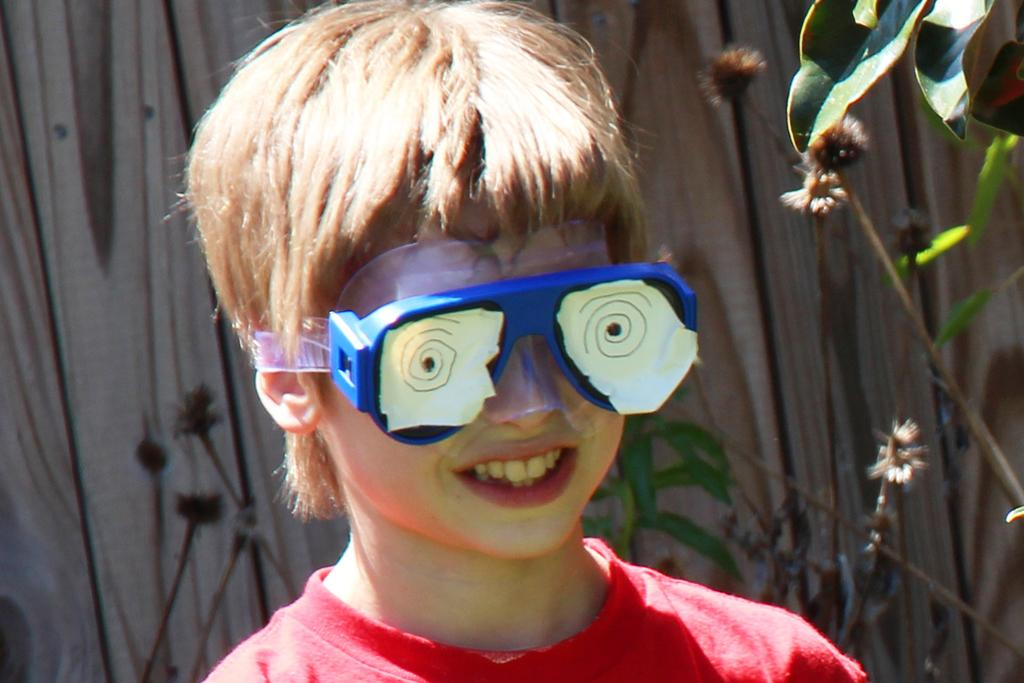What is the main subject of the image? There is a boy standing in the middle of the image. What is the boy wearing in the image? The boy is wearing glasses. What can be seen behind the boy in the image? There are plants visible behind the boy. What type of wall is present in the background of the image? There is a wooden wall in the background. Can you tell me how many girls are standing next to the boy in the image? There is no girl present in the image; only the boy is visible. What type of fruit is being held by the boy in the image? There is no fruit visible in the image; the boy is not holding any fruit. 